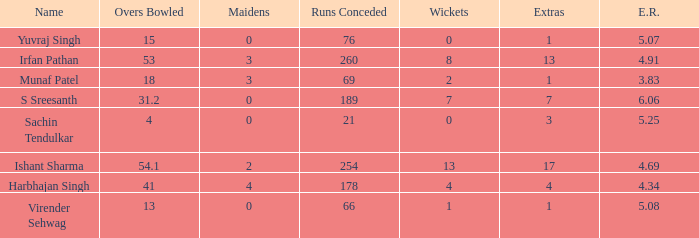Name the wickets for overs bowled being 15 0.0. 